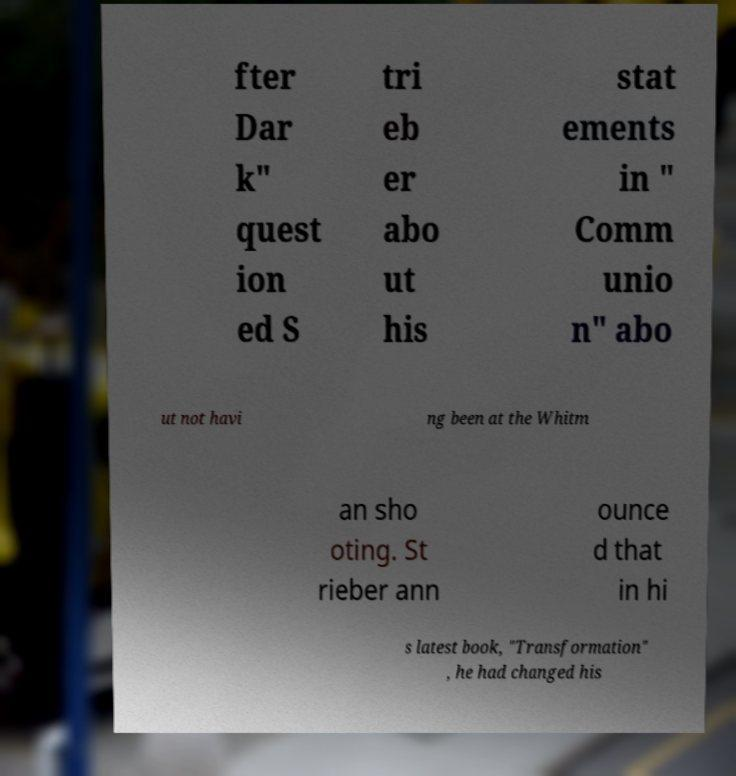Can you read and provide the text displayed in the image?This photo seems to have some interesting text. Can you extract and type it out for me? fter Dar k" quest ion ed S tri eb er abo ut his stat ements in " Comm unio n" abo ut not havi ng been at the Whitm an sho oting. St rieber ann ounce d that in hi s latest book, "Transformation" , he had changed his 